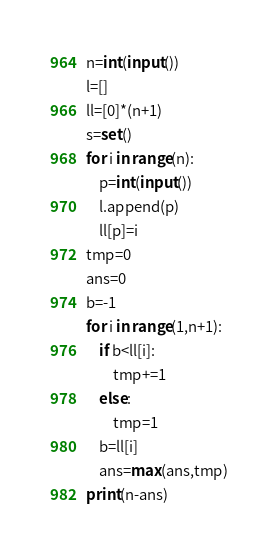Convert code to text. <code><loc_0><loc_0><loc_500><loc_500><_Python_>n=int(input())
l=[]
ll=[0]*(n+1)
s=set()
for i in range(n):
    p=int(input())
    l.append(p)
    ll[p]=i
tmp=0
ans=0
b=-1
for i in range(1,n+1):
    if b<ll[i]:
        tmp+=1
    else:
        tmp=1
    b=ll[i]
    ans=max(ans,tmp)
print(n-ans)



</code> 